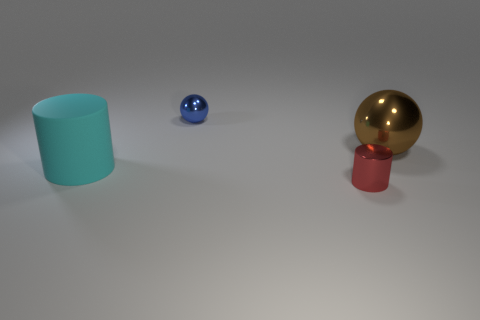Is there any other thing that has the same material as the cyan cylinder?
Your response must be concise. No. How many metallic objects are large brown objects or red things?
Your response must be concise. 2. Is there a ball that has the same material as the tiny cylinder?
Give a very brief answer. Yes. What number of things are things right of the blue sphere or objects that are in front of the cyan rubber cylinder?
Offer a very short reply. 2. How many other things are the same color as the matte cylinder?
Keep it short and to the point. 0. What is the brown sphere made of?
Ensure brevity in your answer.  Metal. There is a ball that is to the left of the brown metallic ball; is its size the same as the large cyan rubber cylinder?
Keep it short and to the point. No. What is the size of the cyan thing that is the same shape as the tiny red object?
Ensure brevity in your answer.  Large. Are there an equal number of large cyan rubber cylinders on the right side of the cyan cylinder and big cyan things on the right side of the small blue metal thing?
Offer a terse response. Yes. What size is the cylinder to the left of the blue metallic thing?
Your answer should be very brief. Large. 